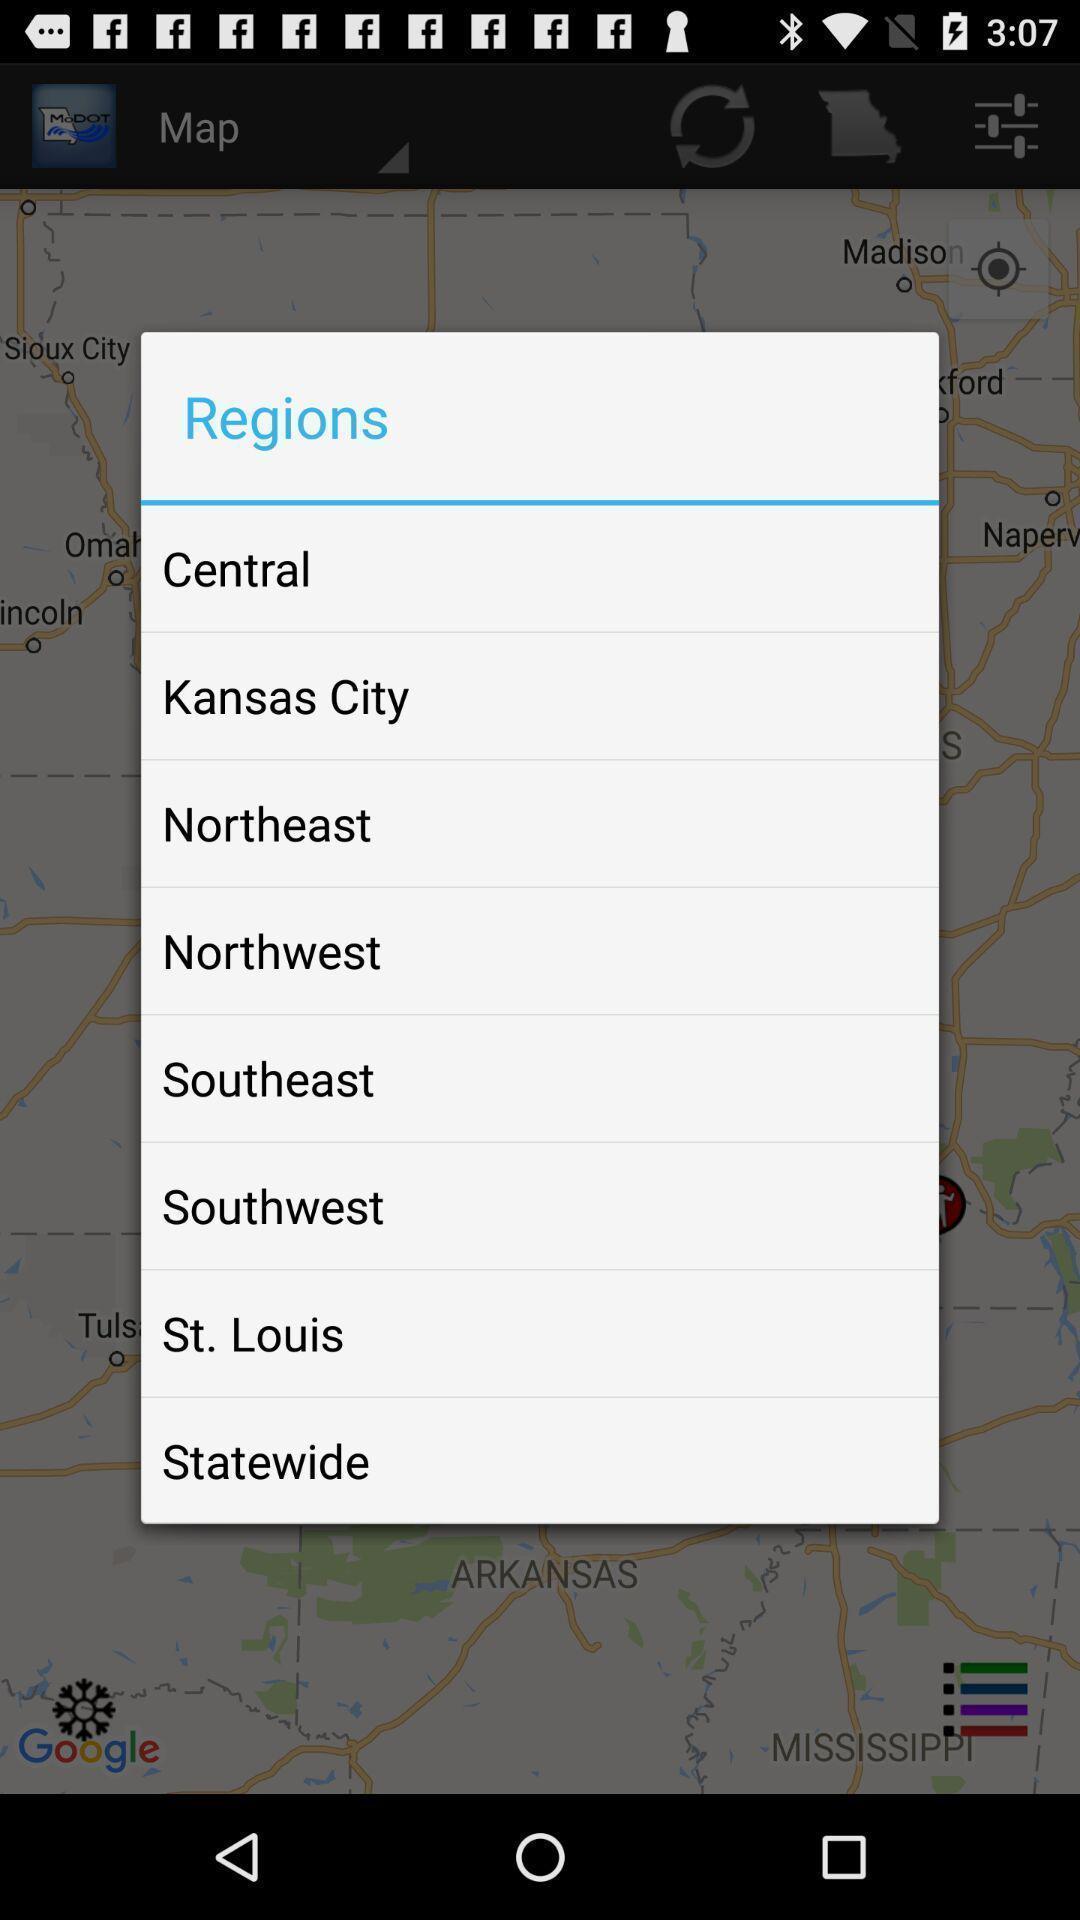What can you discern from this picture? Popup to choose region in the navigation app. 